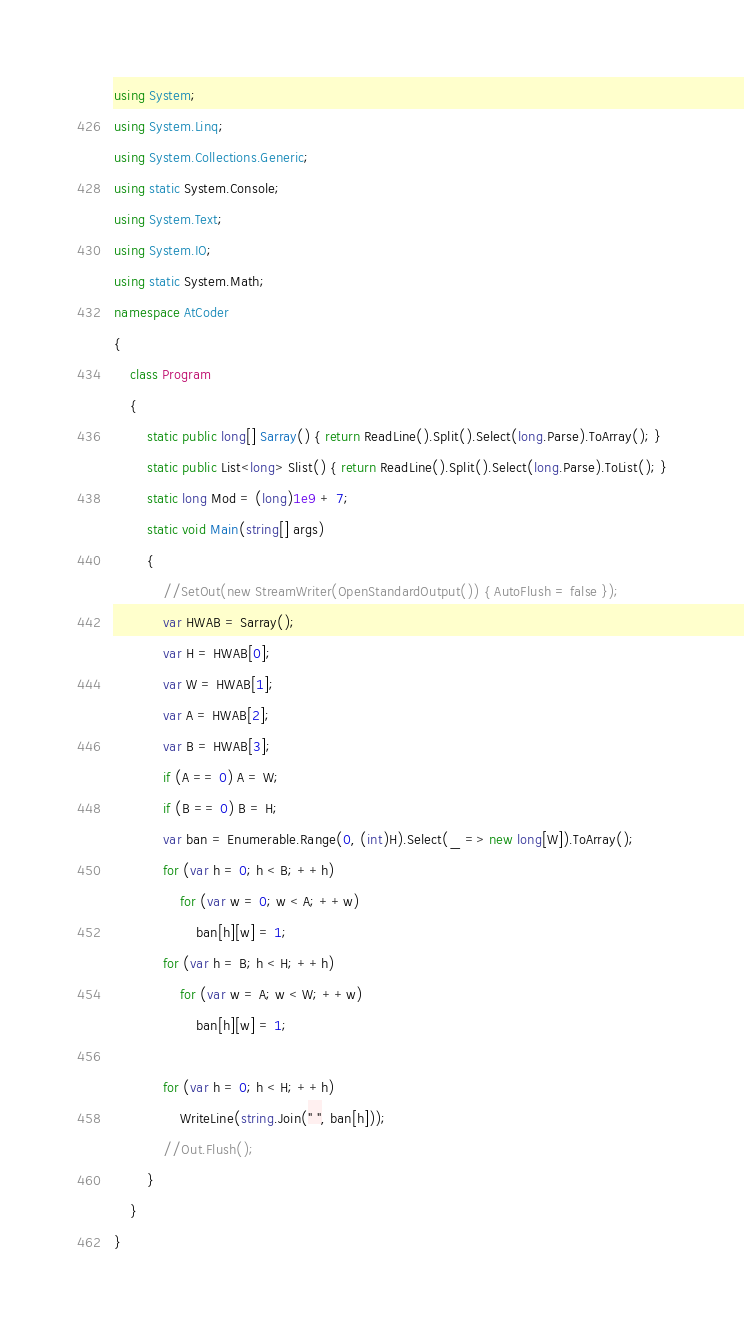Convert code to text. <code><loc_0><loc_0><loc_500><loc_500><_C#_>using System;
using System.Linq;
using System.Collections.Generic;
using static System.Console;
using System.Text;
using System.IO;
using static System.Math;
namespace AtCoder
{
    class Program
    {
        static public long[] Sarray() { return ReadLine().Split().Select(long.Parse).ToArray(); }
        static public List<long> Slist() { return ReadLine().Split().Select(long.Parse).ToList(); }
        static long Mod = (long)1e9 + 7;
        static void Main(string[] args)
        {
            //SetOut(new StreamWriter(OpenStandardOutput()) { AutoFlush = false });
            var HWAB = Sarray();
            var H = HWAB[0];
            var W = HWAB[1];
            var A = HWAB[2];
            var B = HWAB[3];
            if (A == 0) A = W;
            if (B == 0) B = H;
            var ban = Enumerable.Range(0, (int)H).Select(_ => new long[W]).ToArray();
            for (var h = 0; h < B; ++h)
                for (var w = 0; w < A; ++w)
                    ban[h][w] = 1;
            for (var h = B; h < H; ++h)
                for (var w = A; w < W; ++w)
                    ban[h][w] = 1;

            for (var h = 0; h < H; ++h)
                WriteLine(string.Join(" ", ban[h]));
            //Out.Flush();
        }
    }
}</code> 